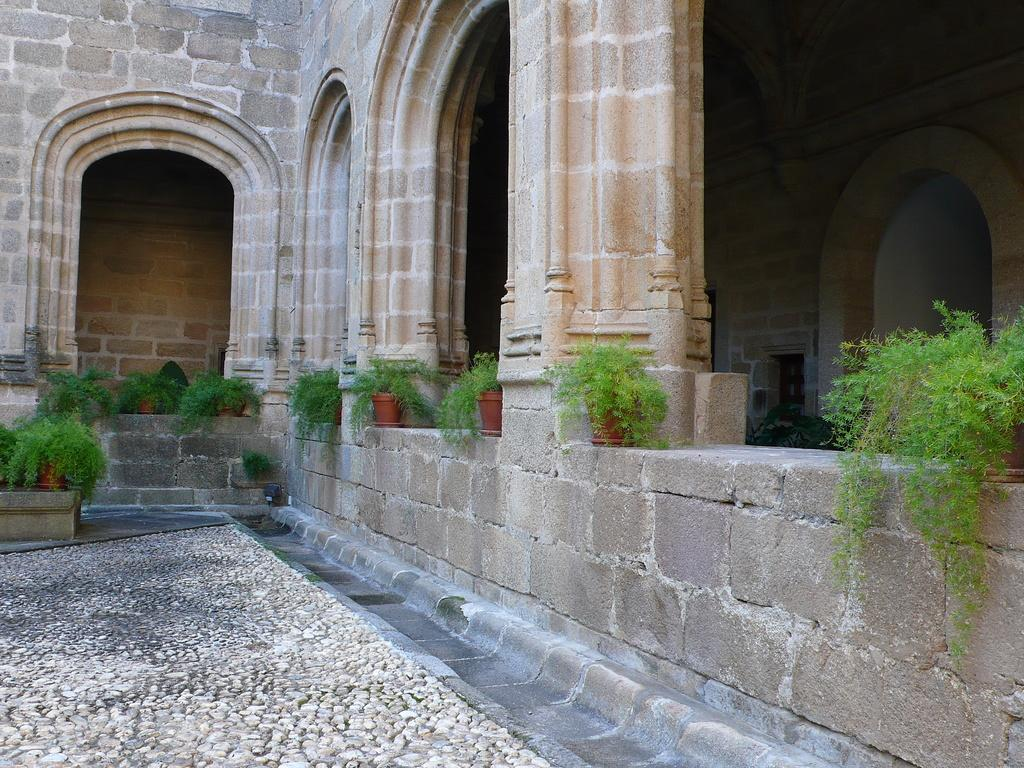What type of structure is visible in the image? There is a building wall with pillars in the image. What other elements can be seen in the image? There are house plants and a path near the building wall in the image. What type of punishment is being administered to the secretary in the image? There is no secretary or punishment present in the image. 